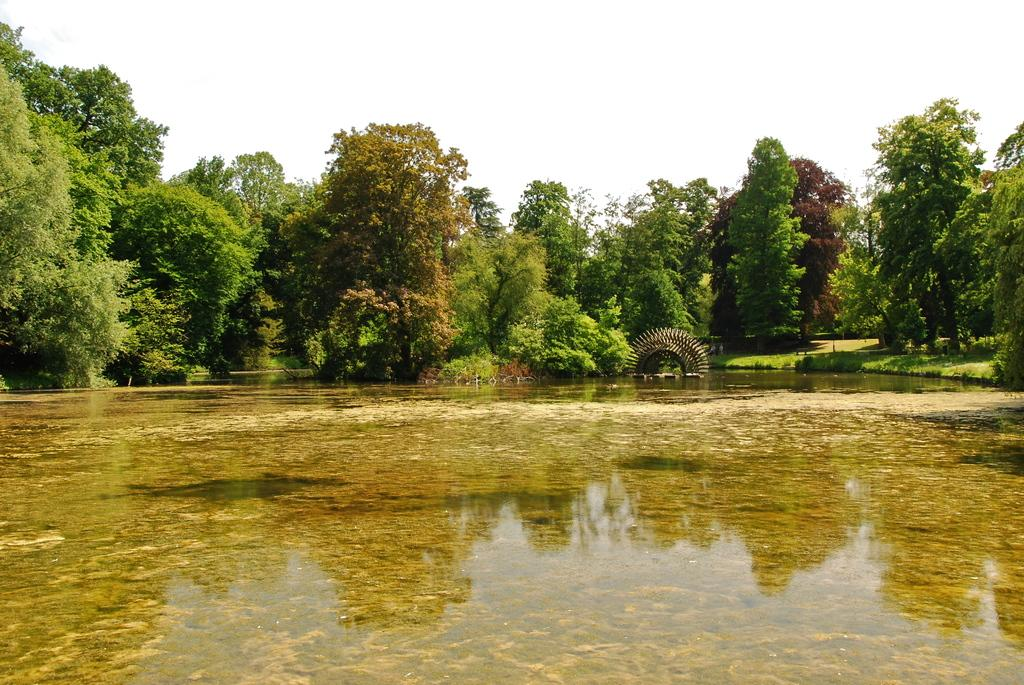What is visible in the image? Water is visible in the image. What can be seen in the background of the image? There are trees in the background of the image. What type of curtain is hanging in the water in the image? There is no curtain present in the image; it features water and trees in the background. What type of food can be seen floating in the water in the image? There is no food visible in the image; it only shows water and trees in the background. 